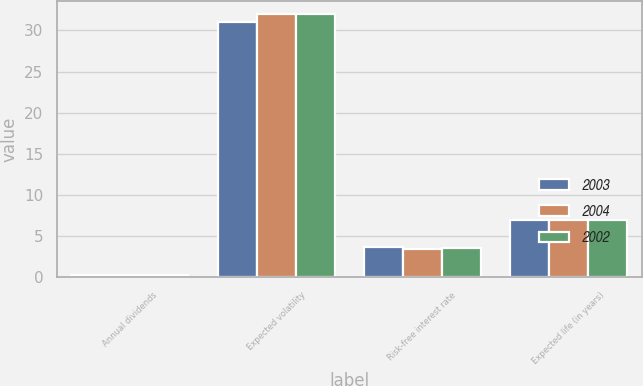Convert chart to OTSL. <chart><loc_0><loc_0><loc_500><loc_500><stacked_bar_chart><ecel><fcel>Annual dividends<fcel>Expected volatility<fcel>Risk-free interest rate<fcel>Expected life (in years)<nl><fcel>2003<fcel>0.32<fcel>31<fcel>3.7<fcel>7<nl><fcel>2004<fcel>0.3<fcel>32<fcel>3.5<fcel>7<nl><fcel>2002<fcel>0.28<fcel>32<fcel>3.6<fcel>7<nl></chart> 